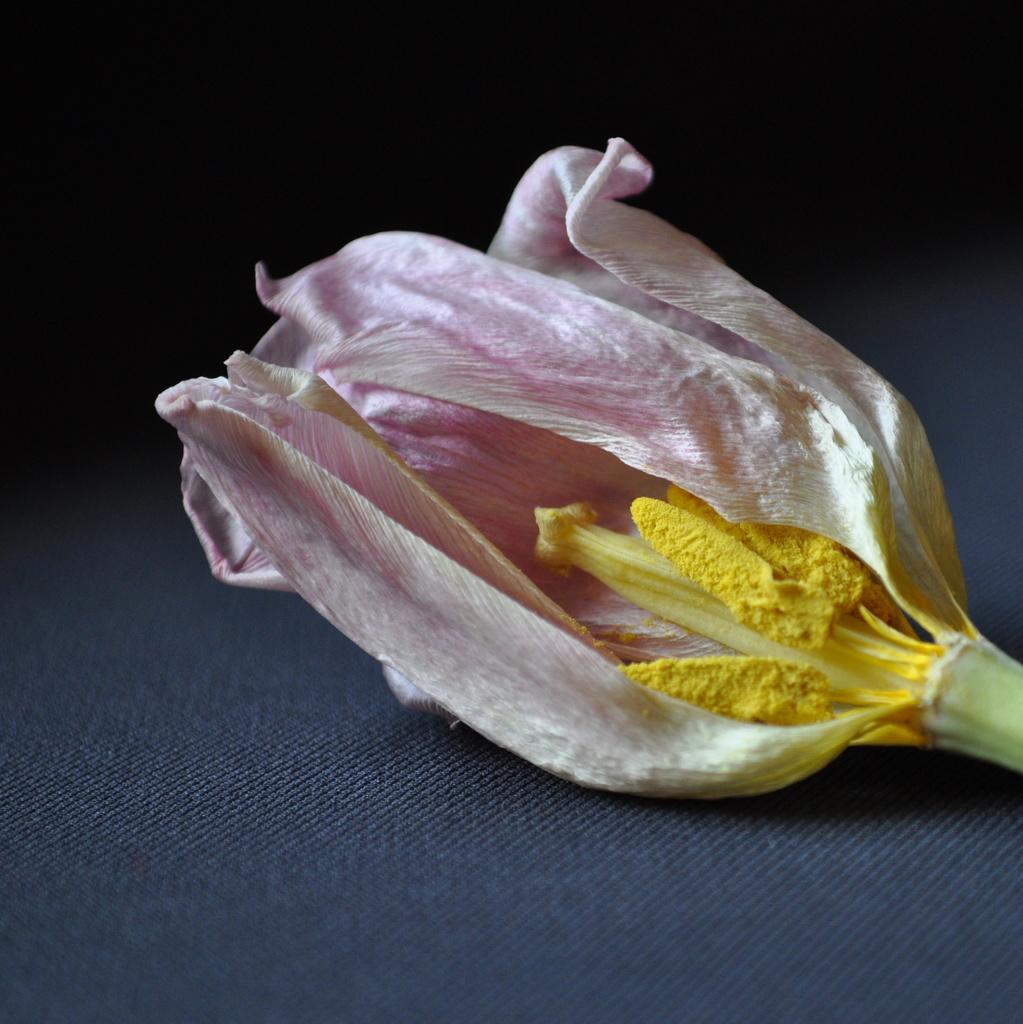Can you describe this image briefly? In the image there is a dry pink flower with yellow stigma on a cloth. 